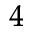<formula> <loc_0><loc_0><loc_500><loc_500>_ { 4 }</formula> 